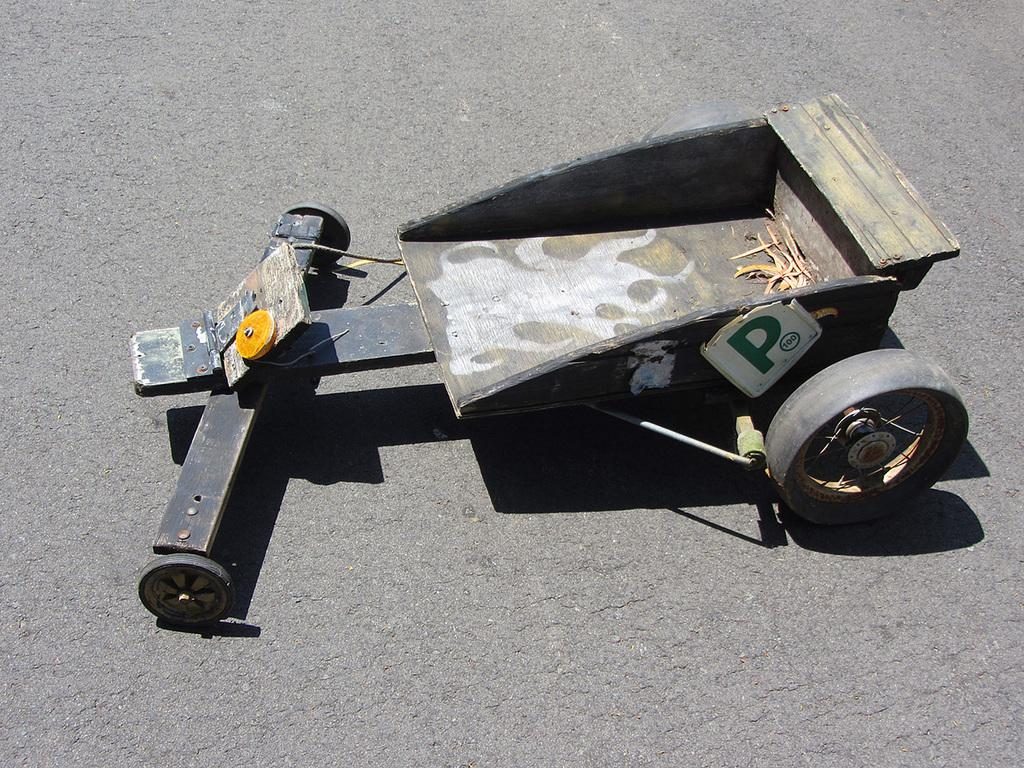What is the main object in the image? There is a cart in the image. Where is the cart located? The cart is on the road. How is the cart positioned in the image? The cart is in the middle of the image. What is the chance of the cart being used in the industry in the image? There is no information about the cart's use or the industry in the image, so it's not possible to determine the chance of the cart being used in the industry. 